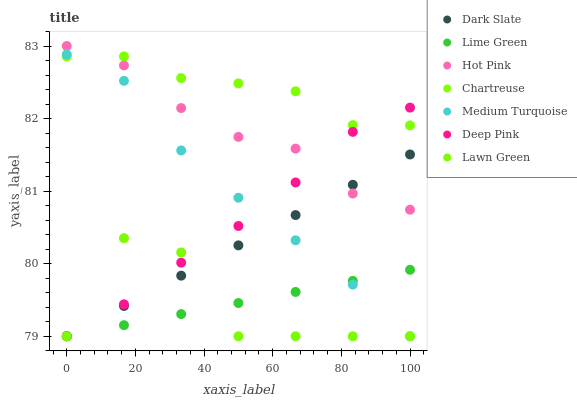Does Lawn Green have the minimum area under the curve?
Answer yes or no. Yes. Does Chartreuse have the maximum area under the curve?
Answer yes or no. Yes. Does Deep Pink have the minimum area under the curve?
Answer yes or no. No. Does Deep Pink have the maximum area under the curve?
Answer yes or no. No. Is Lime Green the smoothest?
Answer yes or no. Yes. Is Lawn Green the roughest?
Answer yes or no. Yes. Is Deep Pink the smoothest?
Answer yes or no. No. Is Deep Pink the roughest?
Answer yes or no. No. Does Lawn Green have the lowest value?
Answer yes or no. Yes. Does Hot Pink have the lowest value?
Answer yes or no. No. Does Hot Pink have the highest value?
Answer yes or no. Yes. Does Deep Pink have the highest value?
Answer yes or no. No. Is Dark Slate less than Chartreuse?
Answer yes or no. Yes. Is Chartreuse greater than Dark Slate?
Answer yes or no. Yes. Does Deep Pink intersect Dark Slate?
Answer yes or no. Yes. Is Deep Pink less than Dark Slate?
Answer yes or no. No. Is Deep Pink greater than Dark Slate?
Answer yes or no. No. Does Dark Slate intersect Chartreuse?
Answer yes or no. No. 